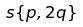Convert formula to latex. <formula><loc_0><loc_0><loc_500><loc_500>s \{ p , 2 q \}</formula> 